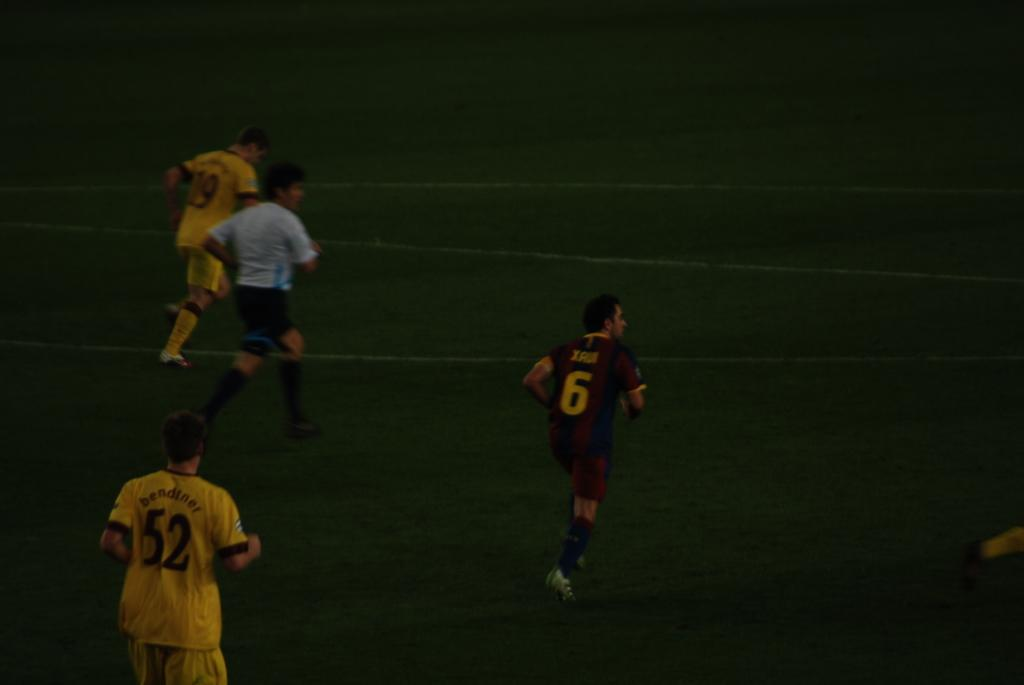Who or what is present in the image? There are people in the image. What are the people doing in the image? The people are running. On what surface are the people running? The running is taking place on grass. What type of cork can be seen on the arm of the person running in the image? There is no cork present on the arm of the person running in the image. What kind of bun is being held by the person running in the image? There is no bun present in the image; the people are running, not holding any baked goods. 